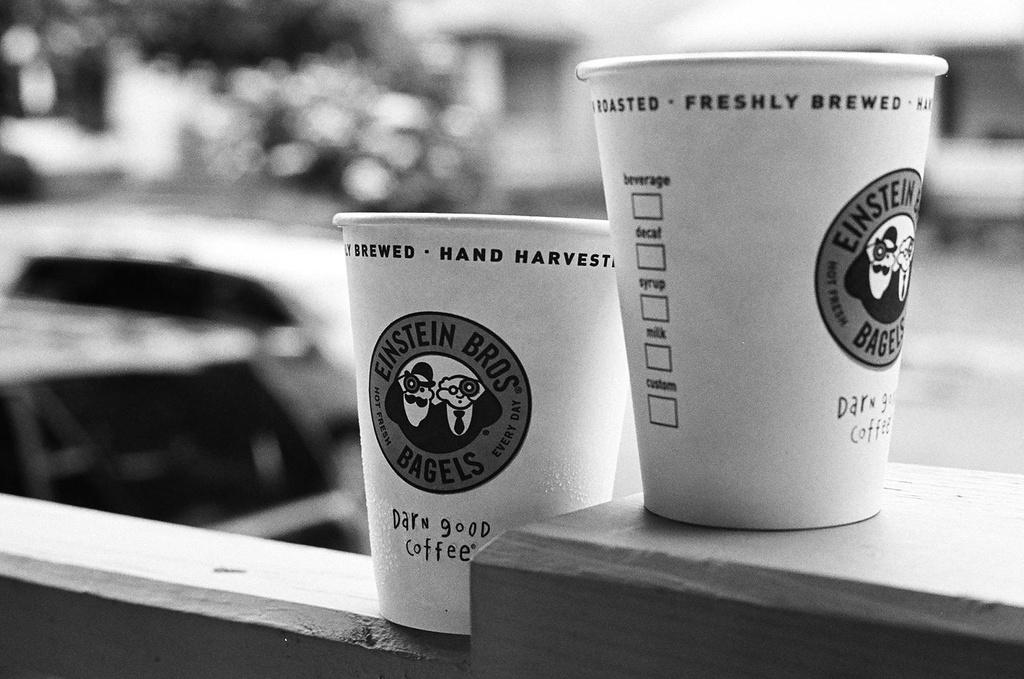How many cups are present in the image? There are two cups in the image. Where are the cups located? The cups are placed on a wall. What can be seen in the background of the image? There is a car visible in the background of the image. How much debt is associated with the cups in the image? There is no information about debt in the image; it only shows two cups placed on a wall and a car in the background. 